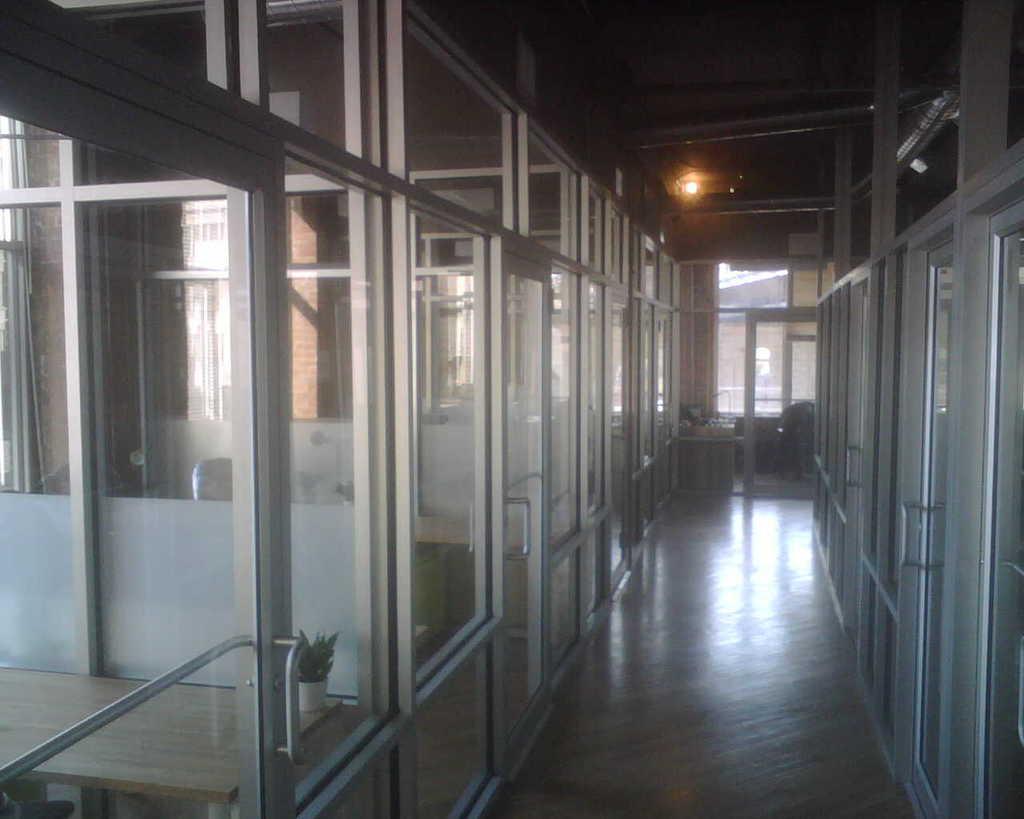In one or two sentences, can you explain what this image depicts? This is an inside view of an building, where there are cabins with glass doors, plant, tables, curtain. 